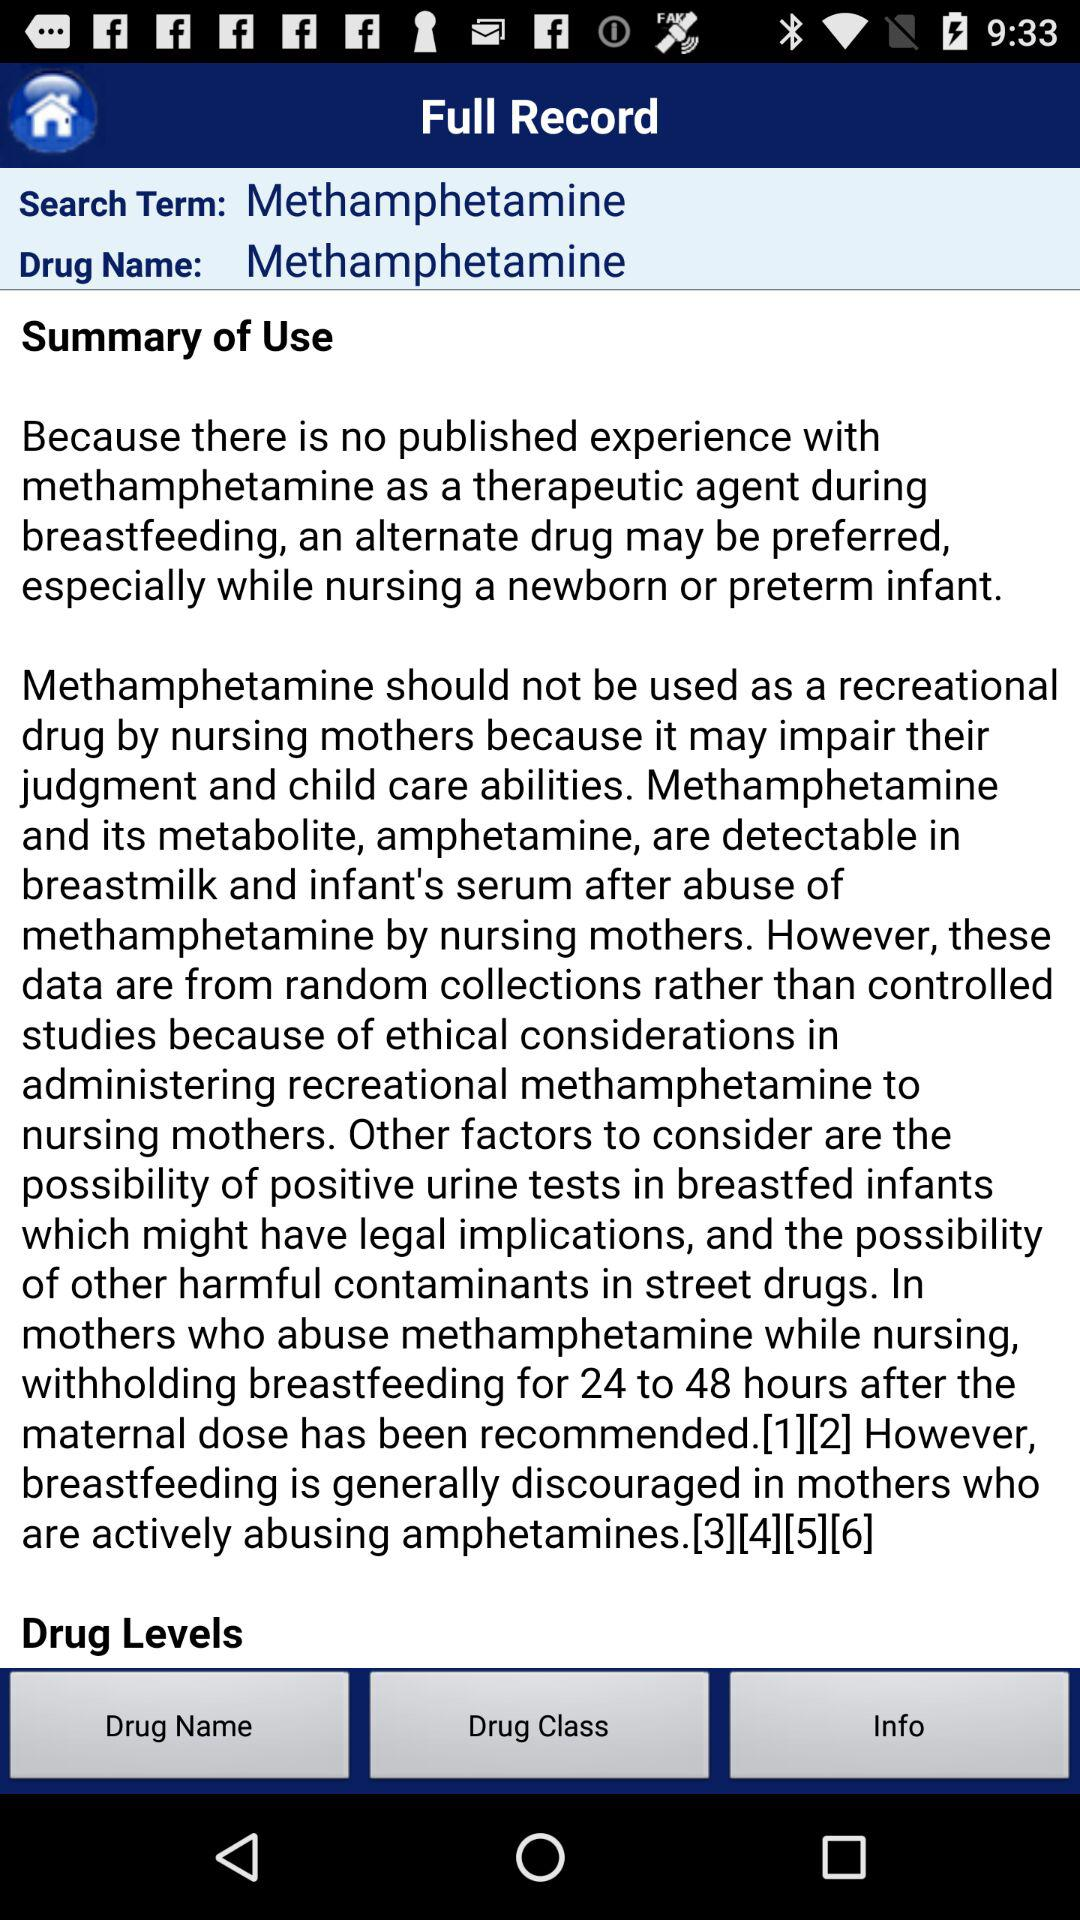What is the search term? The search term is methamphetamine. 